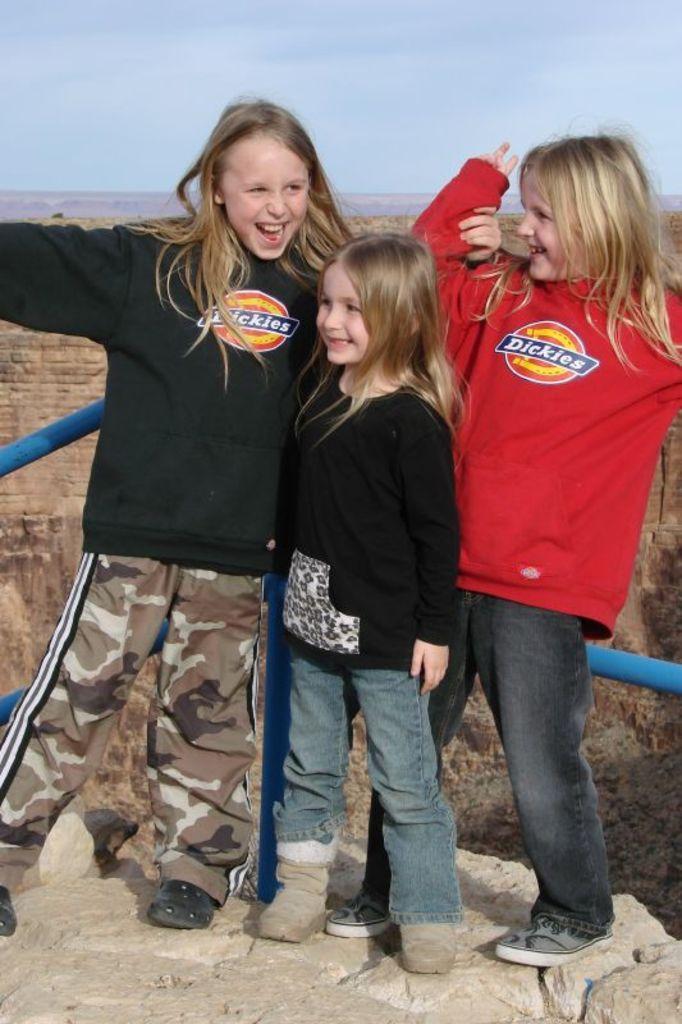Describe this image in one or two sentences. In the picture I can see three girls standing on the rock and there is a smile on their faces. There are clouds in the sky. 